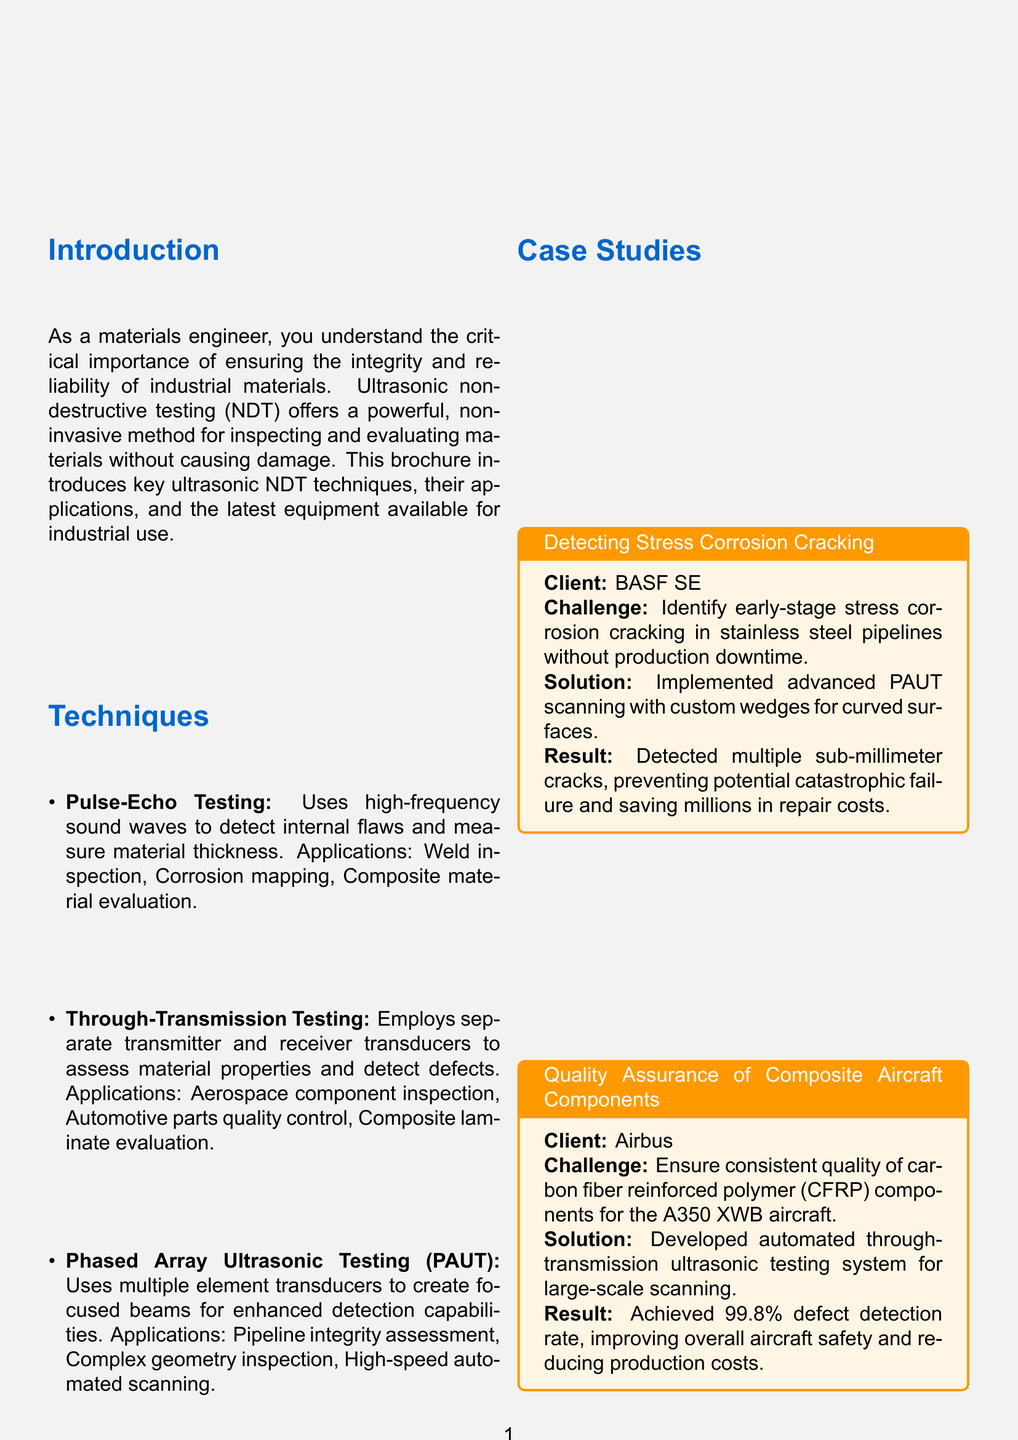What is the title of the brochure? The title of the brochure is provided at the top, introducing the main topic of ultrasonic NDT.
Answer: Ultrasonic Non-Destructive Testing for Industrial Materials Who is the client mentioned in the first case study? The first case study details a project with a specific client, which is listed in the case studies section.
Answer: BASF SE What ultrasonic testing technique uses multiple element transducers? This technique is specifically described in the techniques section, detailing its unique capabilities.
Answer: Phased Array Ultrasonic Testing (PAUT) What is the defect detection rate achieved in the Airbus case study? The case study mentioning Airbus includes a specific statistic regarding defect detection.
Answer: 99.8% What device is manufactured by Waygate Technologies? This question targets the equipment specifications provided in the document.
Answer: Mentor UT What are the applications of the OmniScan X3 device? These applications are listed under its specifications, showcasing its versatility.
Answer: Weld inspection, Corrosion mapping, Composite inspection What is one benefit of using ultrasonic non-destructive testing? The benefits section provides various advantages of using ultrasonic methods for testing.
Answer: Non-invasive inspection preserves material integrity What is the email address of Dr. Emily Chen? The contact information at the end of the document specifies the engineer's email address for inquiries.
Answer: emily.chen@materials-ndt.com What challenge did Airbus face regarding composite aircraft components? The challenge is stated clearly in the corresponding case study in the brochure.
Answer: Ensure consistent quality of carbon fiber reinforced polymer components 